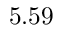Convert formula to latex. <formula><loc_0><loc_0><loc_500><loc_500>5 . 5 9</formula> 